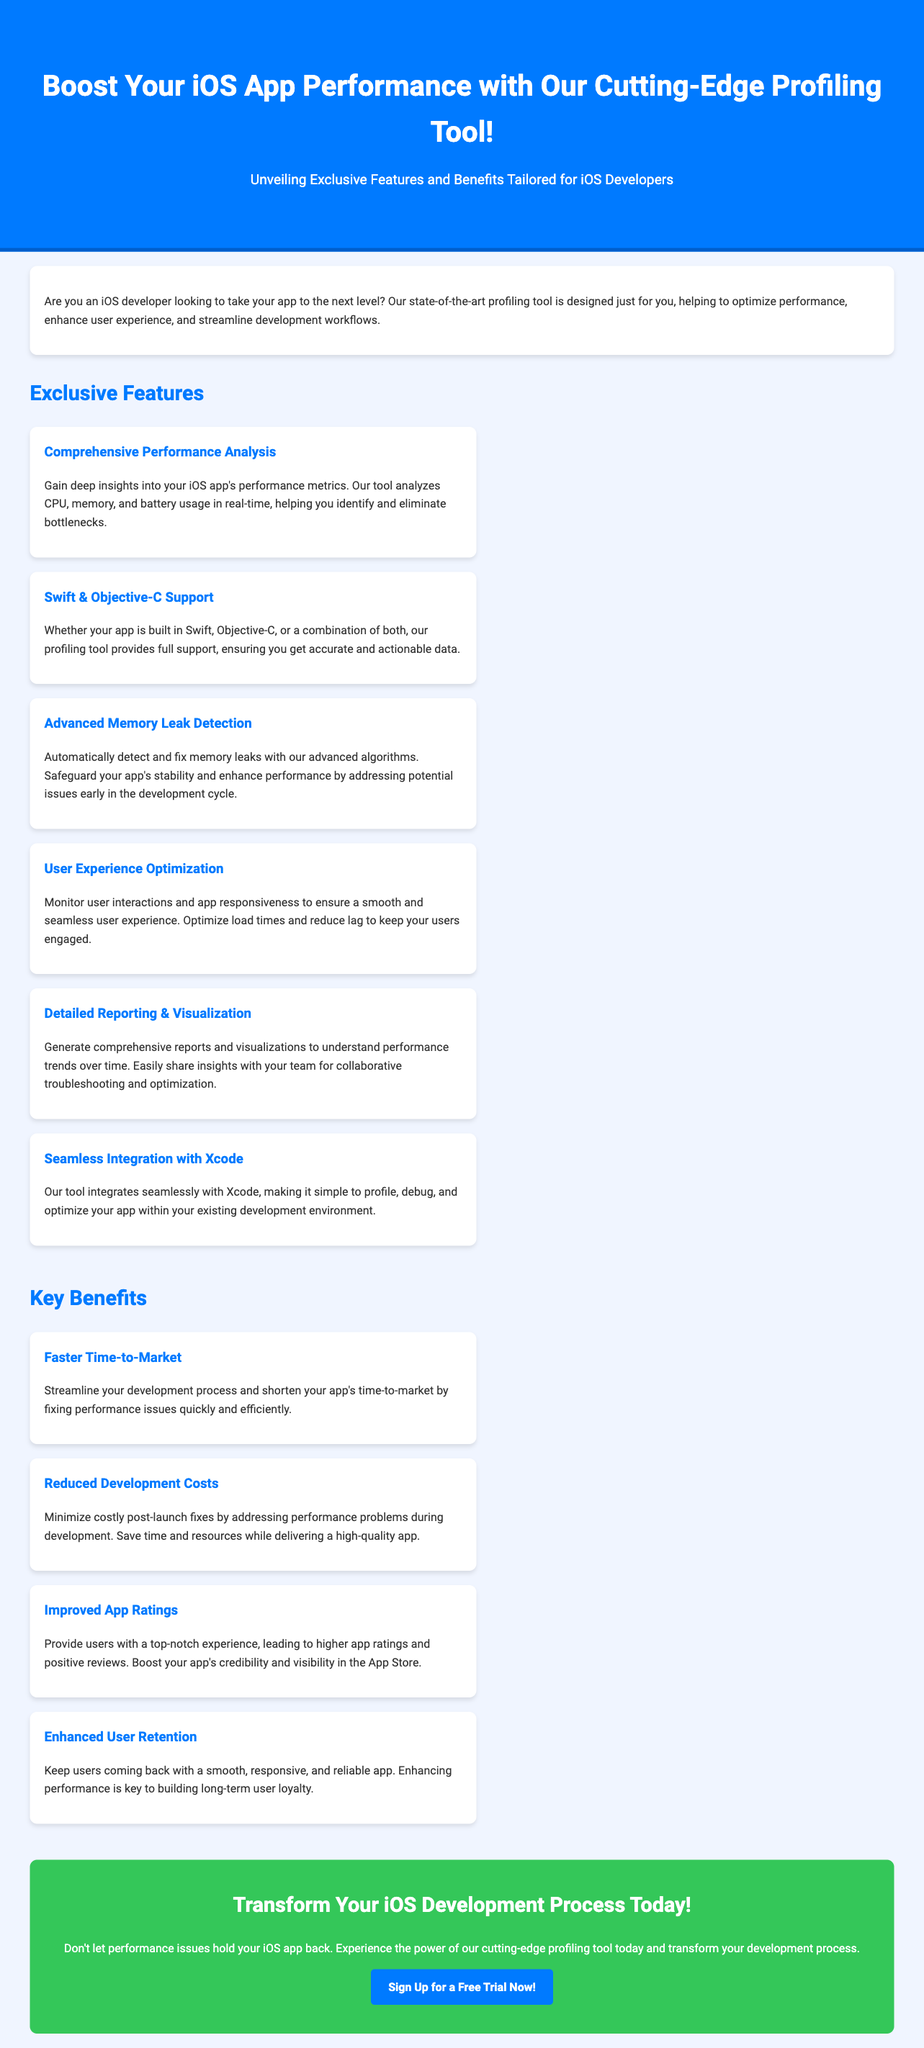What is the title of the advertisement? The title is found in the header section of the document where it provides the main theme of the advertisement.
Answer: Boost Your iOS App Performance with Our Cutting-Edge Profiling Tool! What is a key feature related to memory? This feature specifically addresses issues related to memory management in the app, highlighting its importance.
Answer: Advanced Memory Leak Detection Which programming languages does the tool support? The advertisement specifies two programming languages that the tool can work with in the features section.
Answer: Swift & Objective-C What benefit relates to user experience? The advertisement lists specific benefits that enhance user experience prominently within the key benefits section.
Answer: Enhanced User Retention What visual element is mentioned for performance analysis? This element relates to how developers can view and understand performance in a clear manner.
Answer: Detailed Reporting & Visualization How does the tool integrate with the development environment? The integration aspect describes how users can utilize the tool within their working platform.
Answer: Seamless Integration with Xcode What is one way the tool can impact app ratings? This question focuses on the outcome expected from using the tool regarding user feedback on the app.
Answer: Improved App Ratings What is the call to action? This refers to the specific prompt encouraging users to take the next step as presented towards the end of the advertisement.
Answer: Sign Up for a Free Trial Now! 